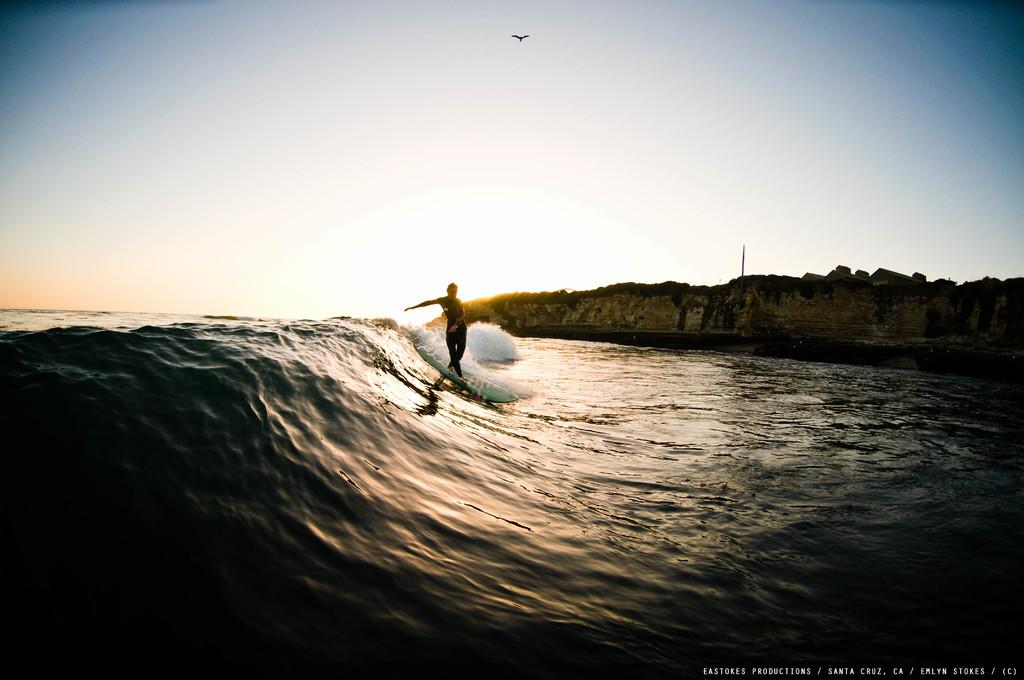What is the person in the image doing? The person is surfing in the image. Where is the person surfing? The person is in the sea. What can be seen on the right side of the image? There is a rock on the right side of the image. What is visible in the background of the image? The sky is visible in the background of the image. Can you describe any other elements in the sky? Yes, there is a bird flying in the sky. Where is the cave located in the image? There is no cave present in the image. What type of spot is the person surfing on in the image? The person is surfing on the surface of the sea, not on a specific spot. 